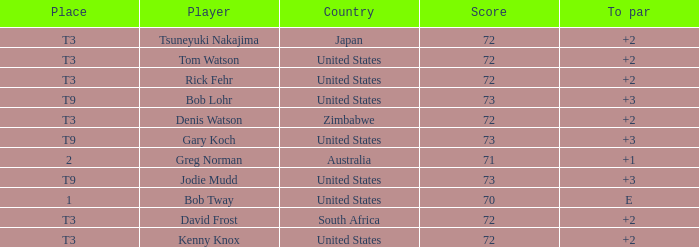Who scored more than 72? Gary Koch, Bob Lohr, Jodie Mudd. 